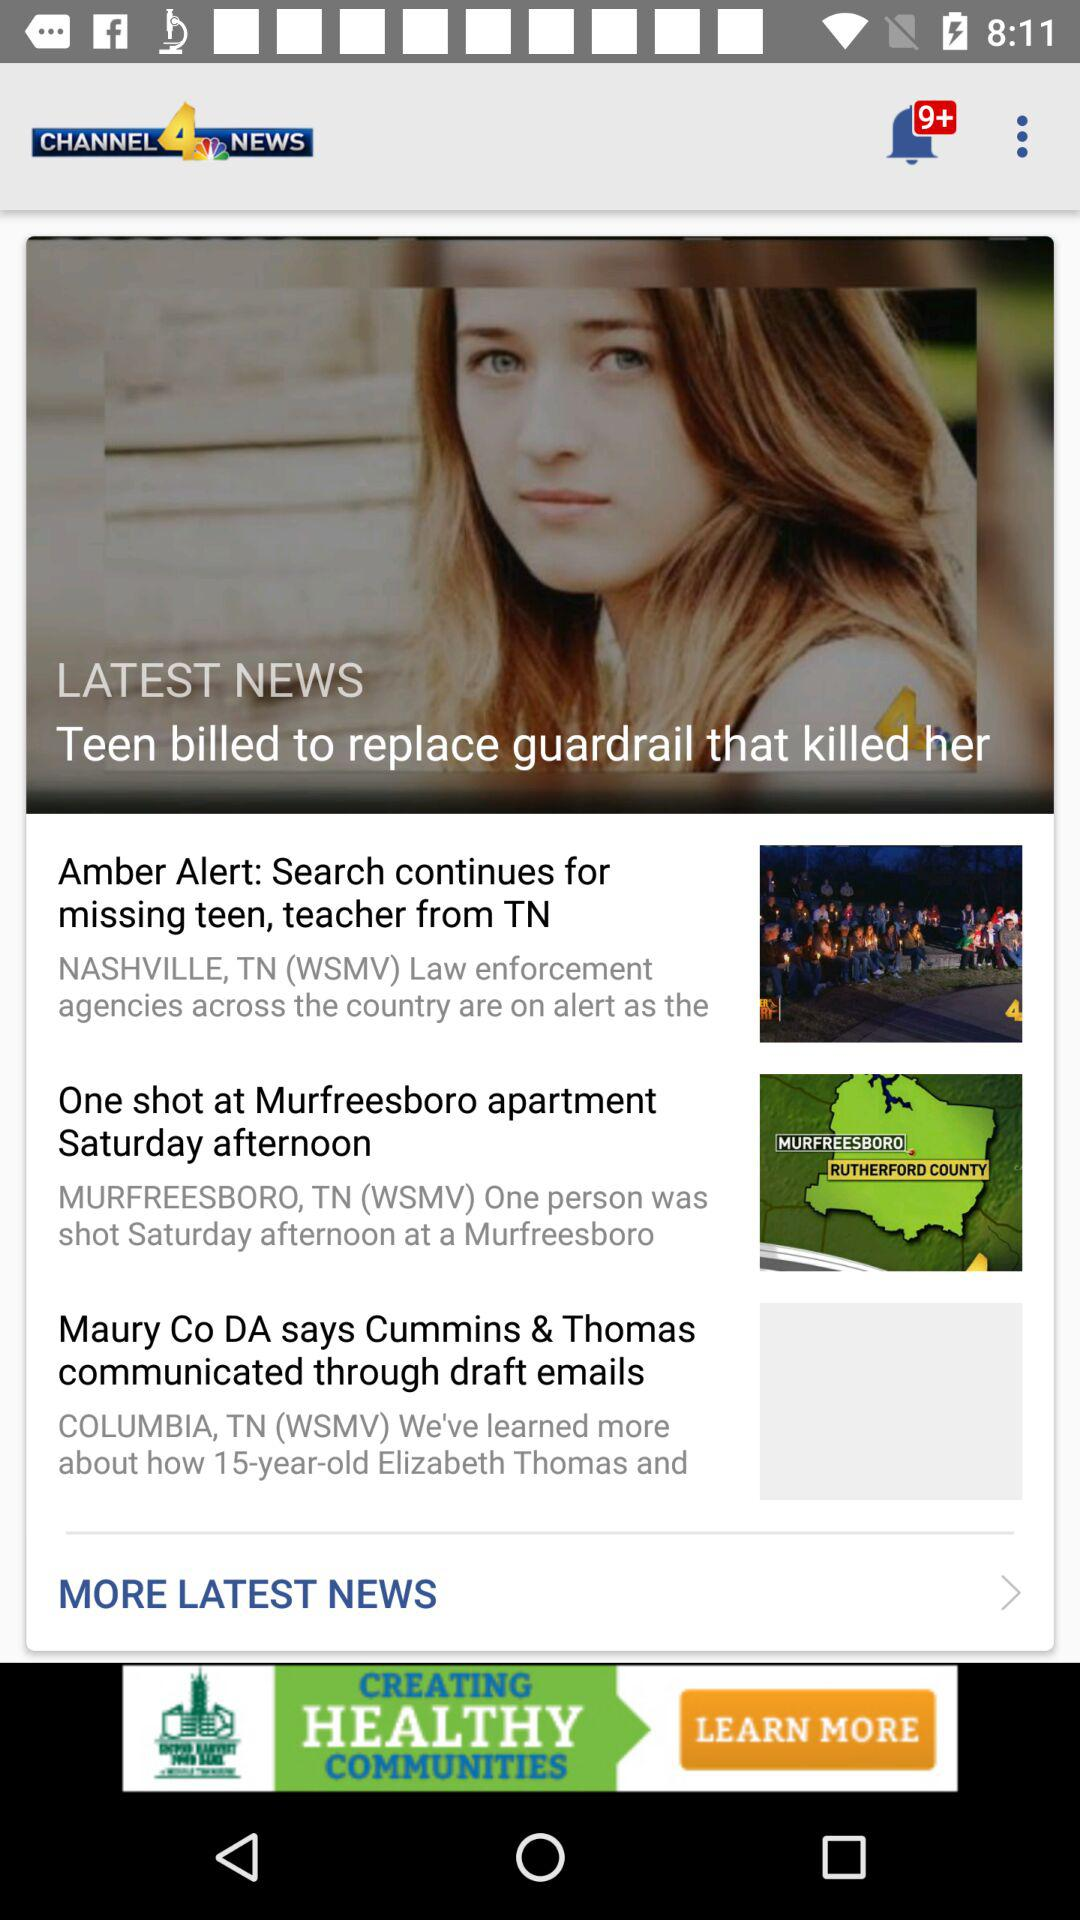What is the application name? The application name is "CHANNEL 4 NEWS". 